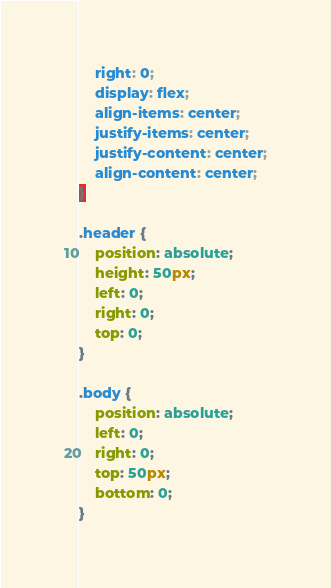Convert code to text. <code><loc_0><loc_0><loc_500><loc_500><_CSS_>    right: 0;
    display: flex;
    align-items: center;
    justify-items: center;
    justify-content: center;
    align-content: center;
}

.header {
    position: absolute;
    height: 50px;
    left: 0;
    right: 0;
    top: 0;
}

.body {
    position: absolute;
    left: 0;
    right: 0;
    top: 50px;
    bottom: 0;
}</code> 